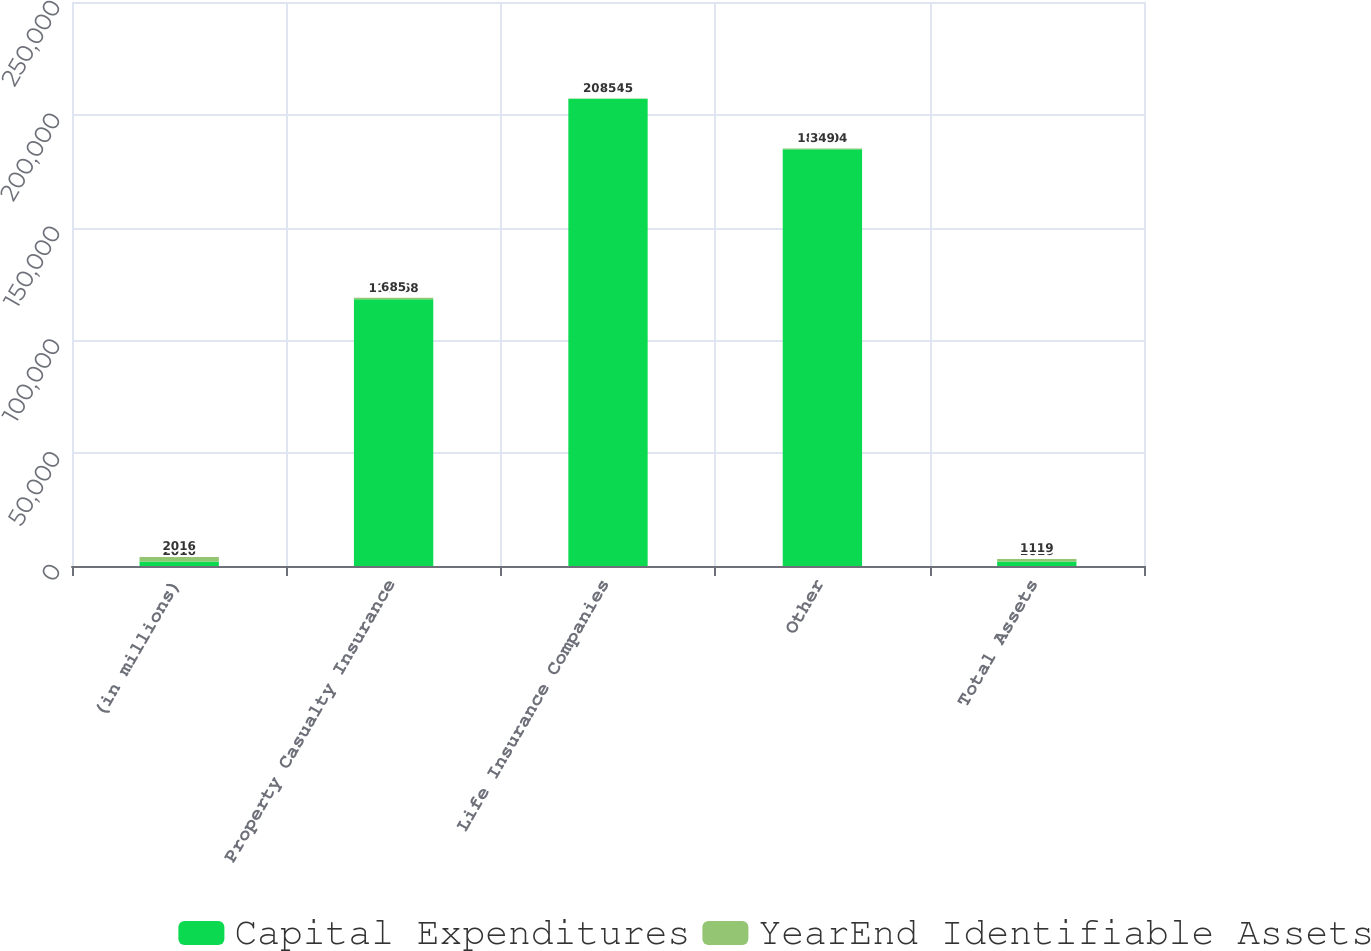Convert chart. <chart><loc_0><loc_0><loc_500><loc_500><stacked_bar_chart><ecel><fcel>(in millions)<fcel>Property Casualty Insurance<fcel>Life Insurance Companies<fcel>Other<fcel>Total Assets<nl><fcel>Capital Expenditures<fcel>2016<fcel>118268<fcel>207145<fcel>184704<fcel>2016<nl><fcel>YearEnd Identifiable Assets<fcel>2016<fcel>685<fcel>85<fcel>349<fcel>1119<nl></chart> 